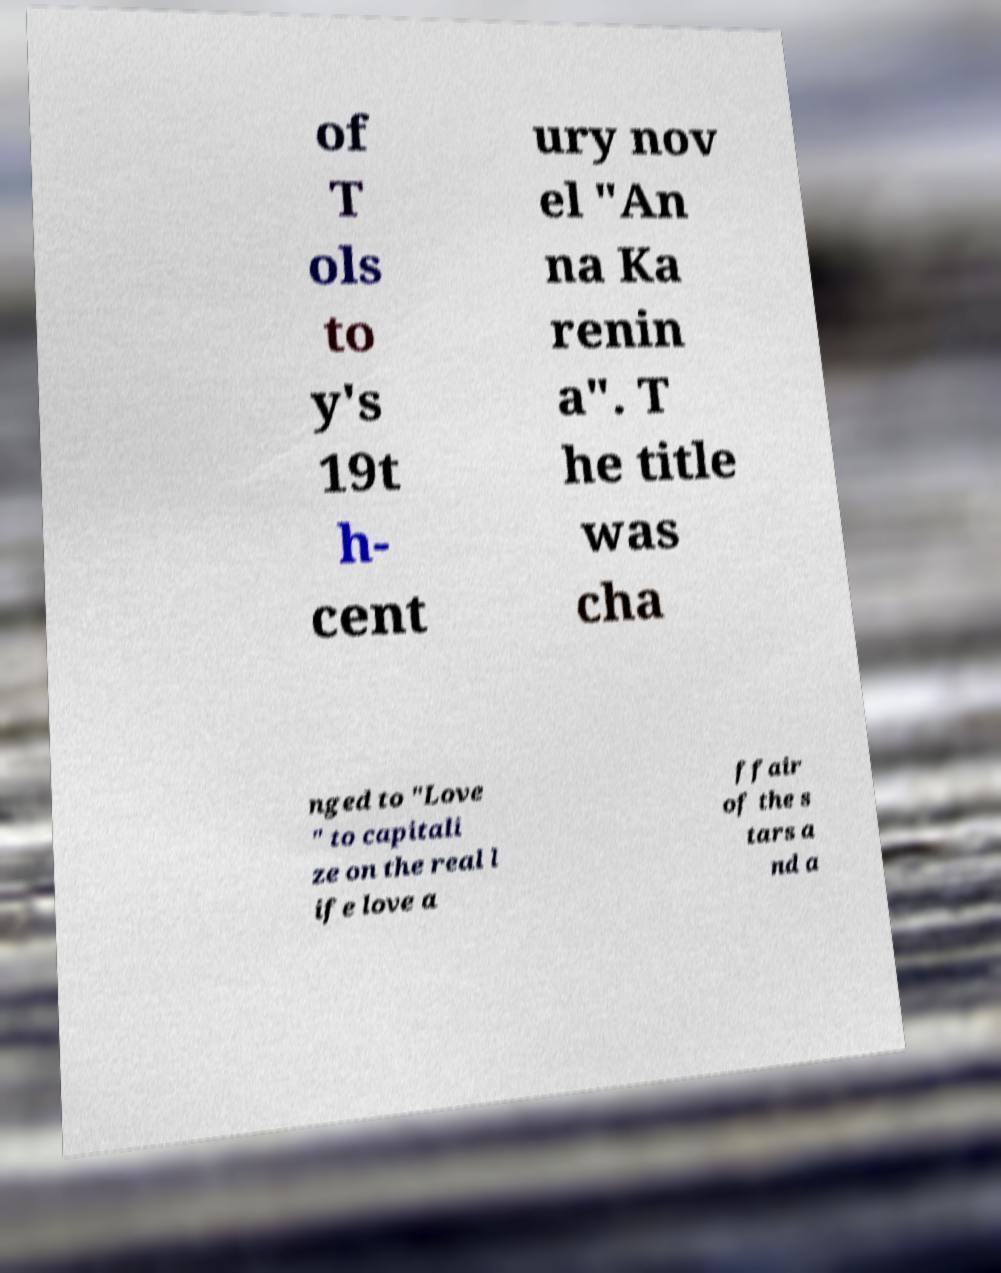I need the written content from this picture converted into text. Can you do that? of T ols to y's 19t h- cent ury nov el "An na Ka renin a". T he title was cha nged to "Love " to capitali ze on the real l ife love a ffair of the s tars a nd a 